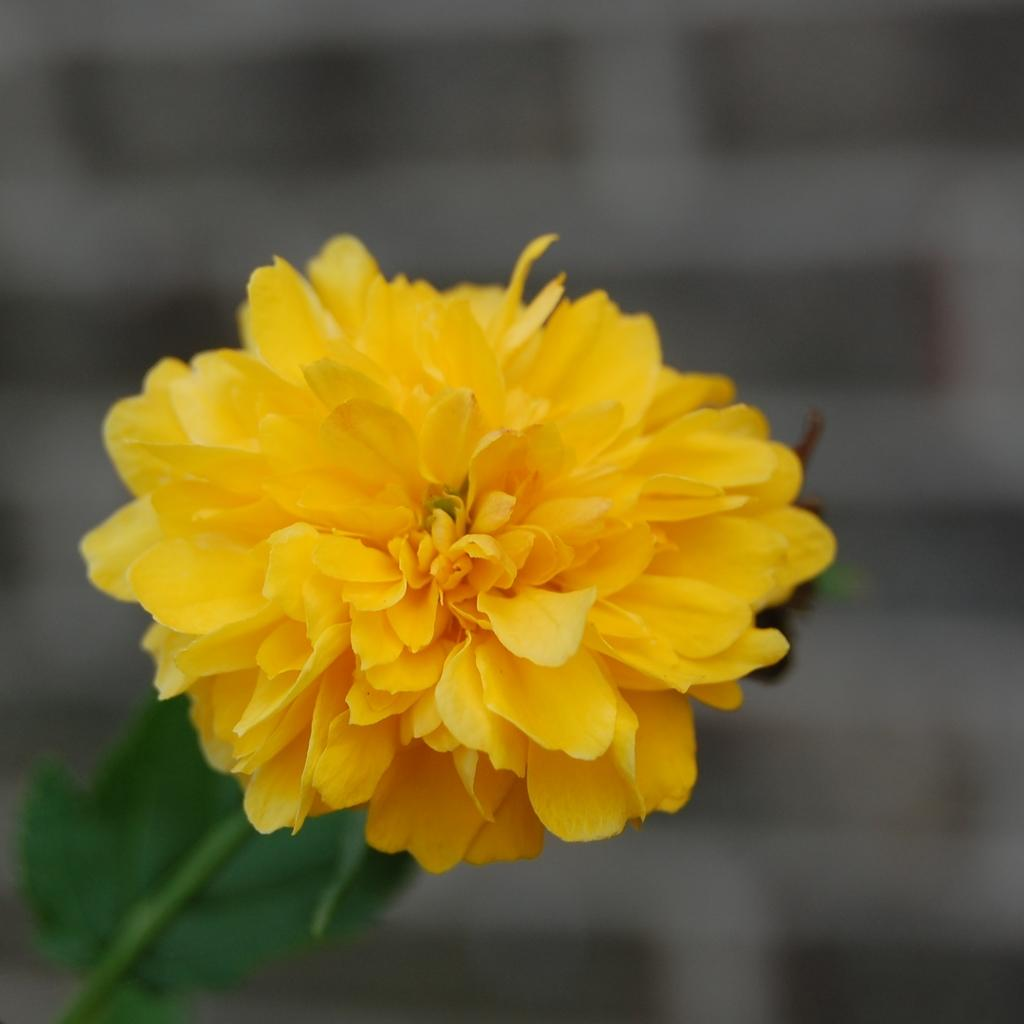What is the main subject of the image? There is a flower in the image. Can you describe the color of the flower? The flower is yellow in color. What type of plastic material is used to create the art in the image? There is no mention of plastic or art in the image; it only features a yellow flower. 